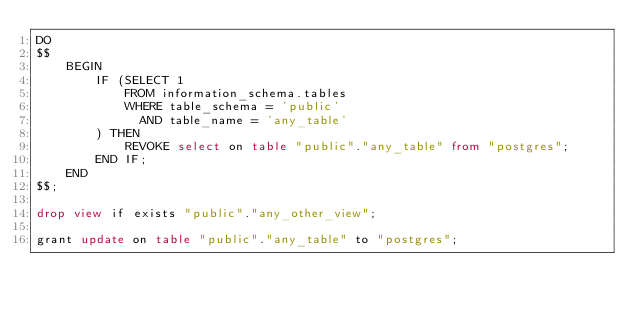Convert code to text. <code><loc_0><loc_0><loc_500><loc_500><_SQL_>DO
$$
    BEGIN
        IF (SELECT 1
            FROM information_schema.tables
            WHERE table_schema = 'public'
              AND table_name = 'any_table'
        ) THEN
            REVOKE select on table "public"."any_table" from "postgres";
        END IF;
    END
$$;

drop view if exists "public"."any_other_view";

grant update on table "public"."any_table" to "postgres";
</code> 